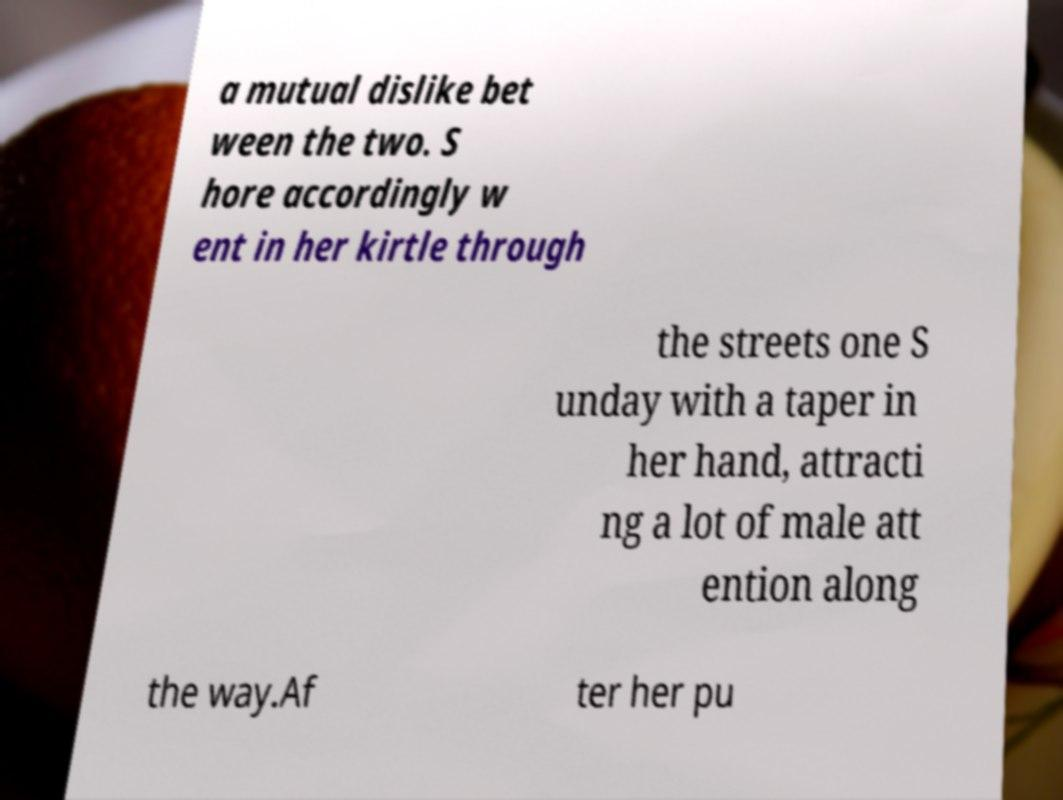There's text embedded in this image that I need extracted. Can you transcribe it verbatim? a mutual dislike bet ween the two. S hore accordingly w ent in her kirtle through the streets one S unday with a taper in her hand, attracti ng a lot of male att ention along the way.Af ter her pu 